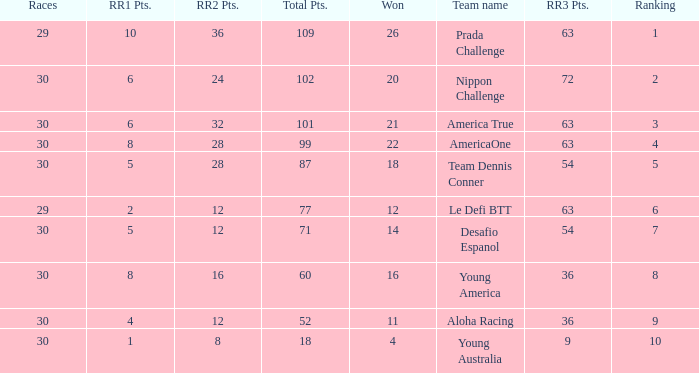Name the total number of rr2 pts for won being 11 1.0. 